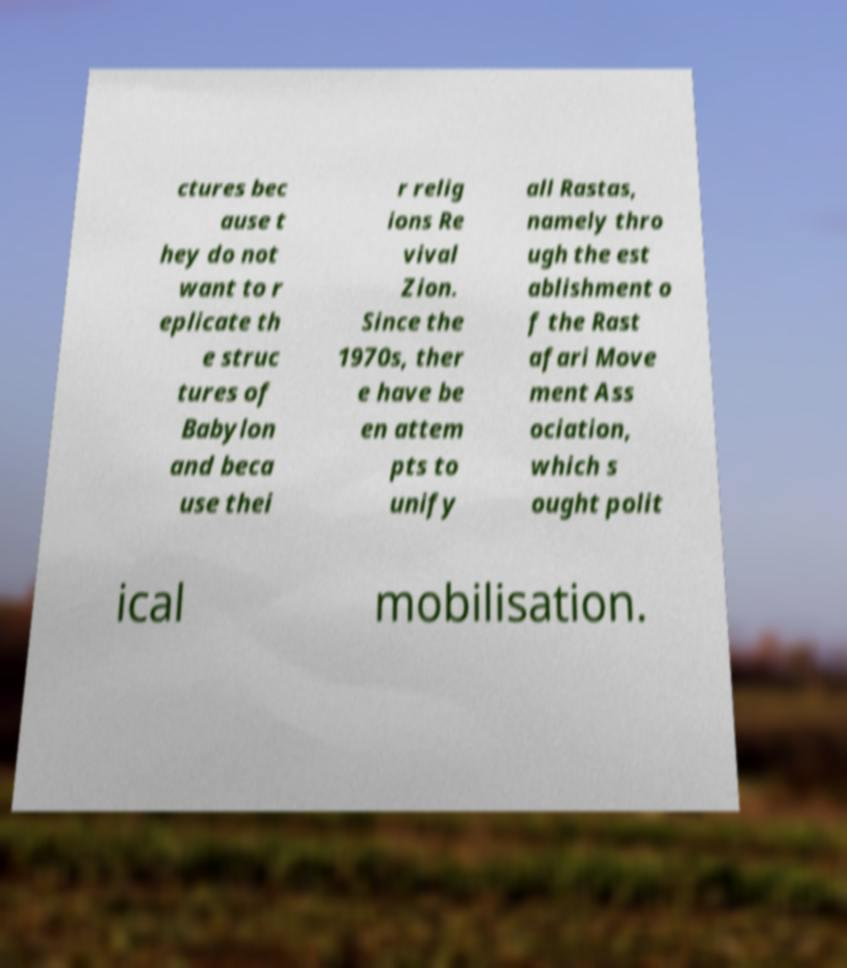I need the written content from this picture converted into text. Can you do that? ctures bec ause t hey do not want to r eplicate th e struc tures of Babylon and beca use thei r relig ions Re vival Zion. Since the 1970s, ther e have be en attem pts to unify all Rastas, namely thro ugh the est ablishment o f the Rast afari Move ment Ass ociation, which s ought polit ical mobilisation. 